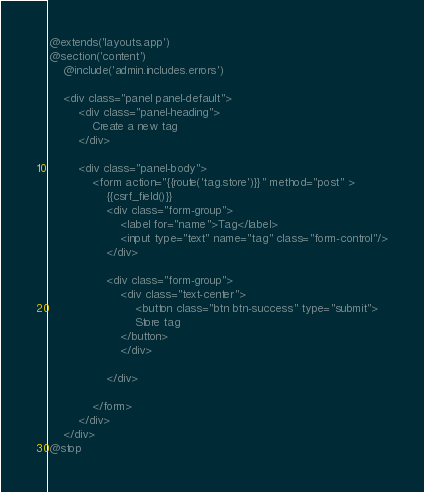Convert code to text. <code><loc_0><loc_0><loc_500><loc_500><_PHP_>@extends('layouts.app')
@section('content')
    @include('admin.includes.errors')

    <div class="panel panel-default">
        <div class="panel-heading">
            Create a new tag
        </div>
        
        <div class="panel-body">
            <form action="{{route('tag.store')}}" method="post" >
                {{csrf_field()}}
                <div class="form-group">
                    <label for="name">Tag</label>
                    <input type="text" name="tag" class="form-control"/>
                </div>
                
                <div class="form-group">
                    <div class="text-center">
                        <button class="btn btn-success" type="submit">
                        Store tag
                    </button>
                    </div>
                    
                </div>
               
            </form>
        </div>
    </div>
@stop</code> 